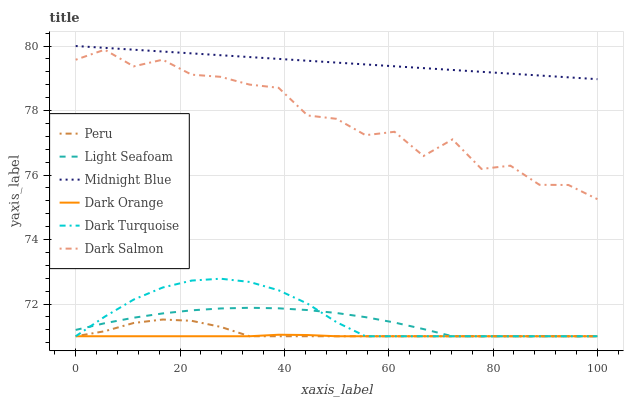Does Dark Orange have the minimum area under the curve?
Answer yes or no. Yes. Does Midnight Blue have the maximum area under the curve?
Answer yes or no. Yes. Does Dark Turquoise have the minimum area under the curve?
Answer yes or no. No. Does Dark Turquoise have the maximum area under the curve?
Answer yes or no. No. Is Midnight Blue the smoothest?
Answer yes or no. Yes. Is Dark Salmon the roughest?
Answer yes or no. Yes. Is Dark Turquoise the smoothest?
Answer yes or no. No. Is Dark Turquoise the roughest?
Answer yes or no. No. Does Dark Orange have the lowest value?
Answer yes or no. Yes. Does Midnight Blue have the lowest value?
Answer yes or no. No. Does Midnight Blue have the highest value?
Answer yes or no. Yes. Does Dark Turquoise have the highest value?
Answer yes or no. No. Is Dark Orange less than Midnight Blue?
Answer yes or no. Yes. Is Midnight Blue greater than Dark Turquoise?
Answer yes or no. Yes. Does Peru intersect Light Seafoam?
Answer yes or no. Yes. Is Peru less than Light Seafoam?
Answer yes or no. No. Is Peru greater than Light Seafoam?
Answer yes or no. No. Does Dark Orange intersect Midnight Blue?
Answer yes or no. No. 